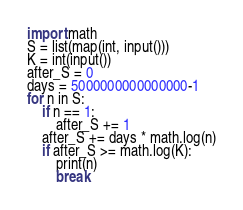<code> <loc_0><loc_0><loc_500><loc_500><_Python_>import math
S = list(map(int, input()))
K = int(input())
after_S = 0
days = 5000000000000000-1
for n in S:
    if n == 1:
        after_S += 1
    after_S += days * math.log(n)
    if after_S >= math.log(K):
        print(n)
        break
</code> 